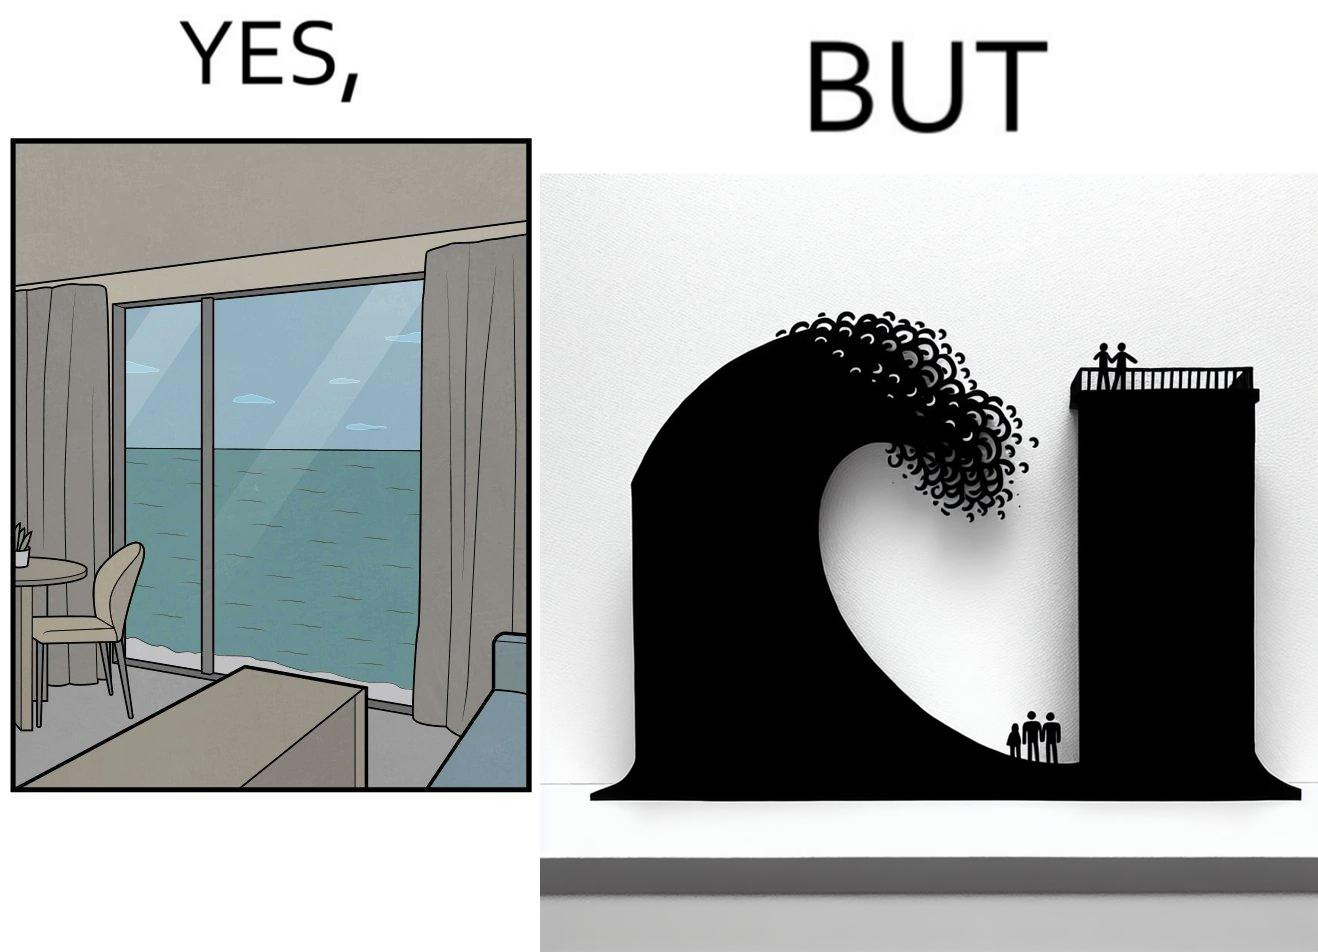Is there satirical content in this image? Yes, this image is satirical. 